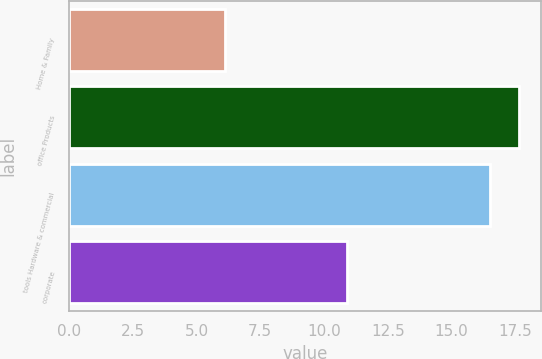Convert chart to OTSL. <chart><loc_0><loc_0><loc_500><loc_500><bar_chart><fcel>Home & Family<fcel>office Products<fcel>tools Hardware & commercial<fcel>corporate<nl><fcel>6.1<fcel>17.64<fcel>16.5<fcel>10.9<nl></chart> 